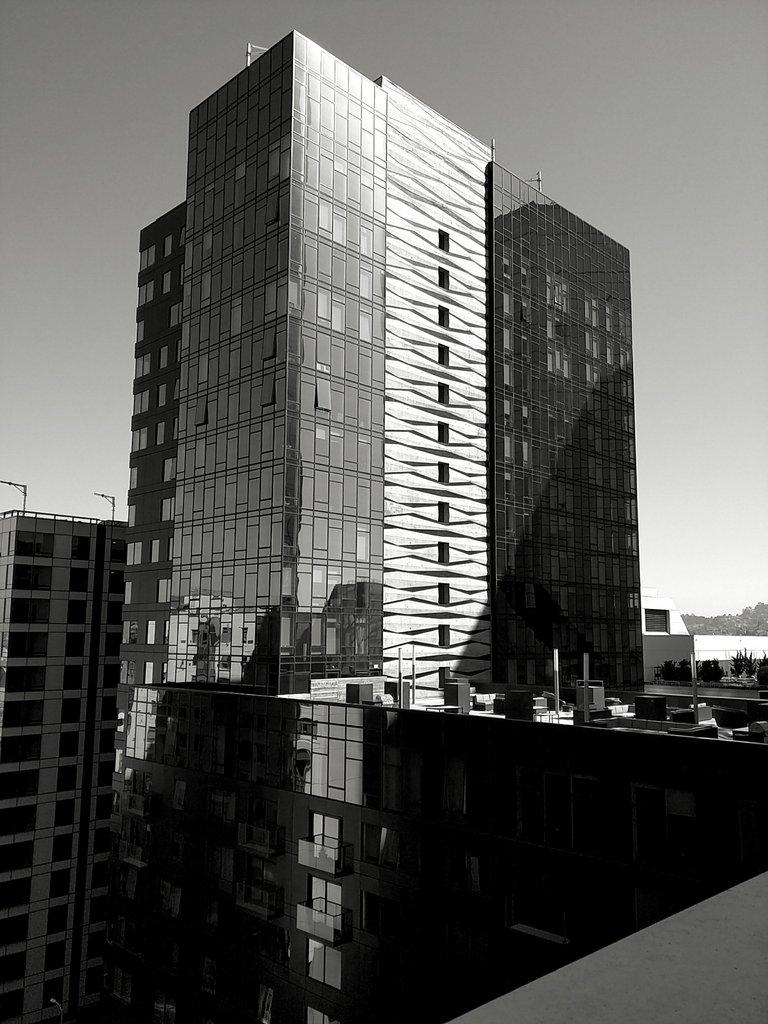What is the color scheme of the image? The image is black and white. What type of structures can be seen in the image? There are buildings in the image. What other elements are present besides the buildings? There are plants visible in the image. What can be seen in the background of the image? There are trees and the sky visible in the background of the image. What type of coil is wrapped around the trees in the image? There is no coil present in the image; it is a black and white image featuring buildings, plants, trees, and the sky. Can you see any eggs in the image? There are no eggs visible in the image. 